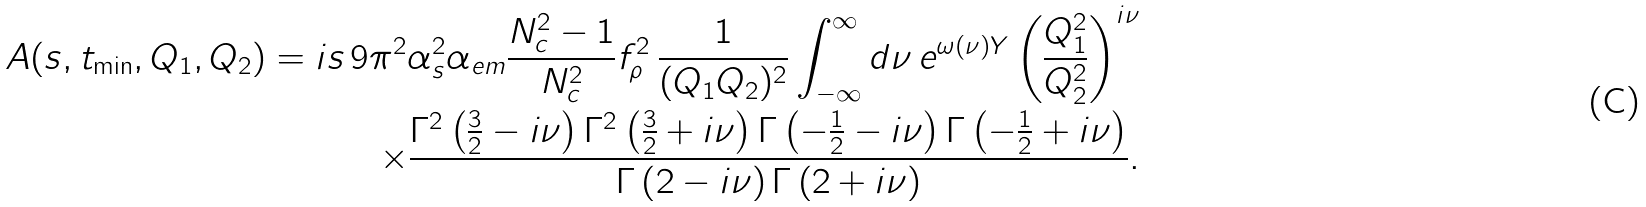<formula> <loc_0><loc_0><loc_500><loc_500>A ( s , t _ { \min } , Q _ { 1 } , Q _ { 2 } ) = i s \, 9 \pi ^ { 2 } \alpha _ { s } ^ { 2 } \alpha _ { e m } \frac { N _ { c } ^ { 2 } - 1 } { N _ { c } ^ { 2 } } f _ { \rho } ^ { 2 } \, \frac { 1 } { ( Q _ { 1 } Q _ { 2 } ) ^ { 2 } } \int _ { - \infty } ^ { \infty } d \nu \, e ^ { \omega ( \nu ) Y } \left ( \frac { Q _ { 1 } ^ { 2 } } { Q _ { 2 } ^ { 2 } } \right ) ^ { i \nu } \\ \times \frac { \Gamma ^ { 2 } \left ( \frac { 3 } { 2 } - i \nu \right ) \Gamma ^ { 2 } \left ( \frac { 3 } { 2 } + i \nu \right ) \Gamma \left ( - \frac { 1 } { 2 } - i \nu \right ) \Gamma \left ( - \frac { 1 } { 2 } + i \nu \right ) } { \Gamma \left ( 2 - i \nu \right ) \Gamma \left ( 2 + i \nu \right ) } .</formula> 